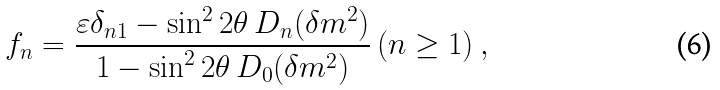<formula> <loc_0><loc_0><loc_500><loc_500>f _ { n } = \frac { \varepsilon \delta _ { n 1 } - \sin ^ { 2 } { 2 \theta } \, D _ { n } ( \delta m ^ { 2 } ) } { 1 - \sin ^ { 2 } { 2 \theta } \, D _ { 0 } ( \delta m ^ { 2 } ) } \, ( n \geq 1 ) \ ,</formula> 